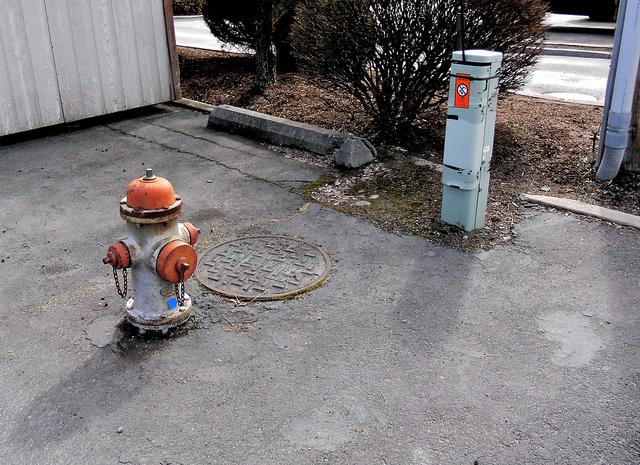Is the ground dry?
Answer briefly. Yes. What's the color of the fire hydrate?
Keep it brief. White and orange. Which one of these devices would a fireman need to use to put out a fire?
Keep it brief. Hydrant. 